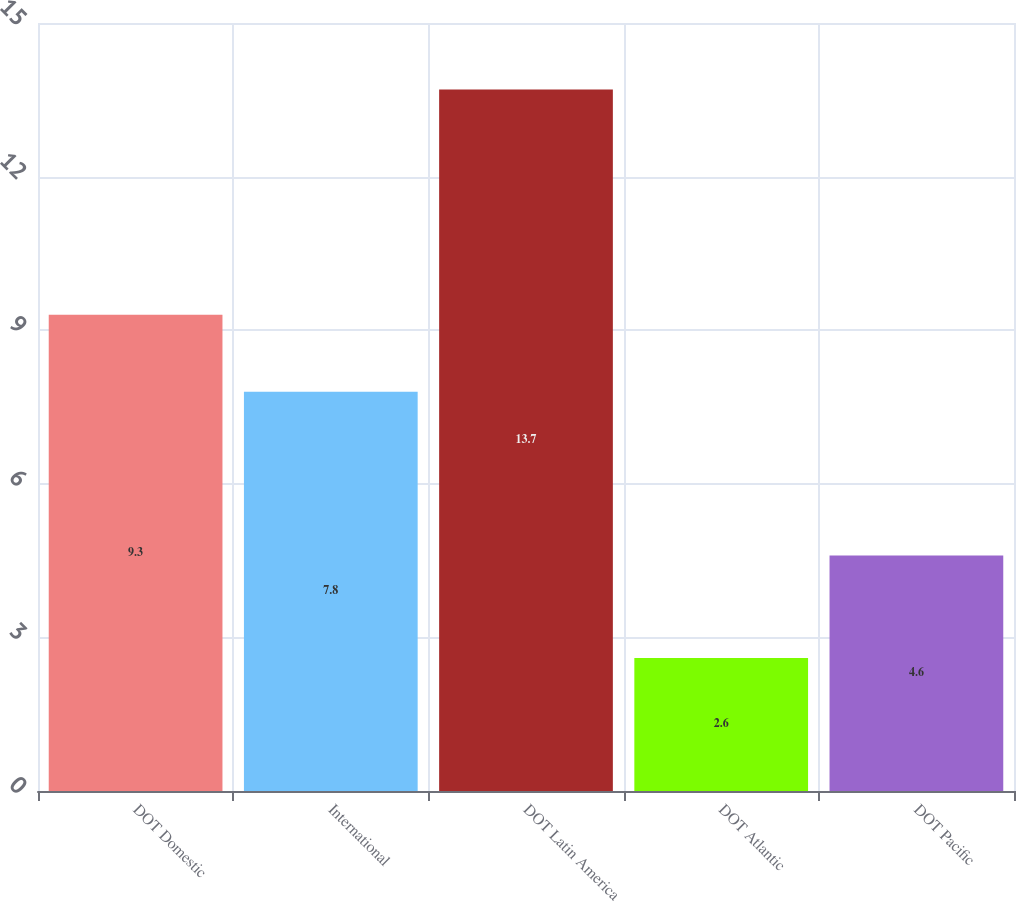Convert chart. <chart><loc_0><loc_0><loc_500><loc_500><bar_chart><fcel>DOT Domestic<fcel>International<fcel>DOT Latin America<fcel>DOT Atlantic<fcel>DOT Pacific<nl><fcel>9.3<fcel>7.8<fcel>13.7<fcel>2.6<fcel>4.6<nl></chart> 